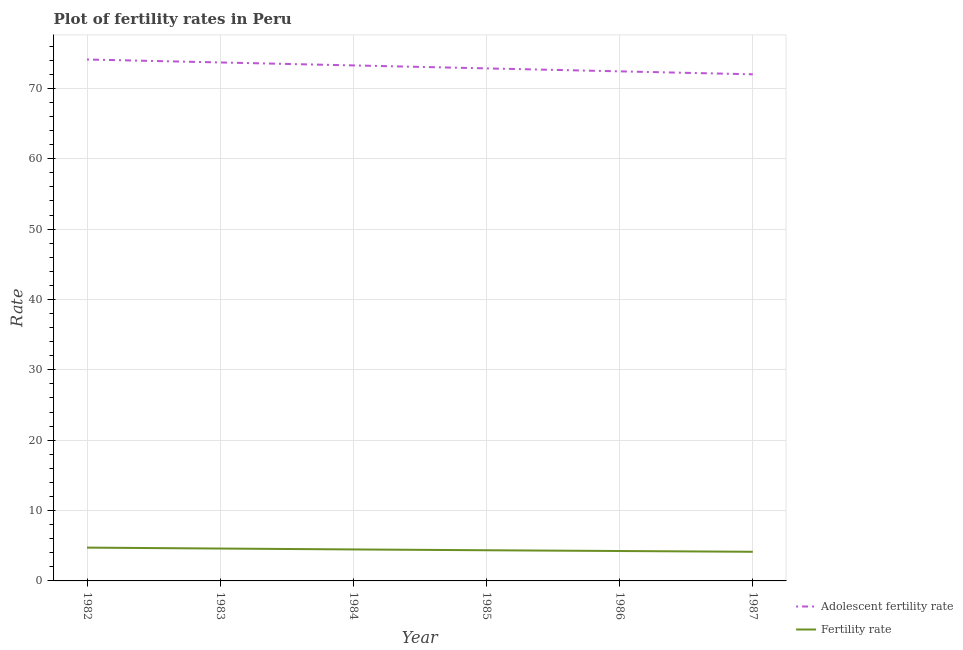How many different coloured lines are there?
Make the answer very short. 2. Is the number of lines equal to the number of legend labels?
Your answer should be compact. Yes. What is the adolescent fertility rate in 1987?
Offer a terse response. 72. Across all years, what is the maximum adolescent fertility rate?
Provide a short and direct response. 74.1. Across all years, what is the minimum fertility rate?
Offer a terse response. 4.14. In which year was the fertility rate maximum?
Offer a very short reply. 1982. In which year was the fertility rate minimum?
Your response must be concise. 1987. What is the total adolescent fertility rate in the graph?
Give a very brief answer. 438.29. What is the difference between the adolescent fertility rate in 1982 and that in 1984?
Your answer should be very brief. 0.84. What is the difference between the adolescent fertility rate in 1986 and the fertility rate in 1983?
Keep it short and to the point. 67.82. What is the average adolescent fertility rate per year?
Ensure brevity in your answer.  73.05. In the year 1984, what is the difference between the fertility rate and adolescent fertility rate?
Provide a short and direct response. -68.78. In how many years, is the adolescent fertility rate greater than 10?
Your response must be concise. 6. What is the ratio of the fertility rate in 1982 to that in 1985?
Keep it short and to the point. 1.09. Is the adolescent fertility rate in 1985 less than that in 1987?
Provide a short and direct response. No. Is the difference between the adolescent fertility rate in 1983 and 1984 greater than the difference between the fertility rate in 1983 and 1984?
Offer a terse response. Yes. What is the difference between the highest and the second highest adolescent fertility rate?
Keep it short and to the point. 0.42. What is the difference between the highest and the lowest fertility rate?
Ensure brevity in your answer.  0.59. Is the adolescent fertility rate strictly greater than the fertility rate over the years?
Ensure brevity in your answer.  Yes. Is the fertility rate strictly less than the adolescent fertility rate over the years?
Offer a very short reply. Yes. How many lines are there?
Your response must be concise. 2. How many years are there in the graph?
Give a very brief answer. 6. Does the graph contain any zero values?
Give a very brief answer. No. Does the graph contain grids?
Keep it short and to the point. Yes. Where does the legend appear in the graph?
Keep it short and to the point. Bottom right. How many legend labels are there?
Give a very brief answer. 2. What is the title of the graph?
Your response must be concise. Plot of fertility rates in Peru. What is the label or title of the Y-axis?
Provide a succinct answer. Rate. What is the Rate of Adolescent fertility rate in 1982?
Provide a succinct answer. 74.1. What is the Rate of Fertility rate in 1982?
Give a very brief answer. 4.73. What is the Rate of Adolescent fertility rate in 1983?
Give a very brief answer. 73.68. What is the Rate of Fertility rate in 1983?
Your answer should be very brief. 4.6. What is the Rate in Adolescent fertility rate in 1984?
Give a very brief answer. 73.26. What is the Rate of Fertility rate in 1984?
Ensure brevity in your answer.  4.47. What is the Rate in Adolescent fertility rate in 1985?
Offer a terse response. 72.84. What is the Rate of Fertility rate in 1985?
Provide a succinct answer. 4.36. What is the Rate in Adolescent fertility rate in 1986?
Your answer should be compact. 72.42. What is the Rate of Fertility rate in 1986?
Keep it short and to the point. 4.25. What is the Rate of Adolescent fertility rate in 1987?
Provide a succinct answer. 72. What is the Rate in Fertility rate in 1987?
Offer a terse response. 4.14. Across all years, what is the maximum Rate of Adolescent fertility rate?
Offer a very short reply. 74.1. Across all years, what is the maximum Rate in Fertility rate?
Give a very brief answer. 4.73. Across all years, what is the minimum Rate in Adolescent fertility rate?
Your response must be concise. 72. Across all years, what is the minimum Rate of Fertility rate?
Your answer should be very brief. 4.14. What is the total Rate in Adolescent fertility rate in the graph?
Ensure brevity in your answer.  438.29. What is the total Rate of Fertility rate in the graph?
Give a very brief answer. 26.56. What is the difference between the Rate in Adolescent fertility rate in 1982 and that in 1983?
Provide a short and direct response. 0.42. What is the difference between the Rate of Fertility rate in 1982 and that in 1983?
Keep it short and to the point. 0.13. What is the difference between the Rate of Adolescent fertility rate in 1982 and that in 1984?
Provide a short and direct response. 0.84. What is the difference between the Rate of Fertility rate in 1982 and that in 1984?
Give a very brief answer. 0.26. What is the difference between the Rate of Adolescent fertility rate in 1982 and that in 1985?
Your answer should be compact. 1.26. What is the difference between the Rate of Fertility rate in 1982 and that in 1985?
Offer a very short reply. 0.38. What is the difference between the Rate in Adolescent fertility rate in 1982 and that in 1986?
Keep it short and to the point. 1.68. What is the difference between the Rate of Fertility rate in 1982 and that in 1986?
Offer a terse response. 0.48. What is the difference between the Rate in Adolescent fertility rate in 1982 and that in 1987?
Your response must be concise. 2.11. What is the difference between the Rate in Fertility rate in 1982 and that in 1987?
Provide a short and direct response. 0.59. What is the difference between the Rate in Adolescent fertility rate in 1983 and that in 1984?
Your response must be concise. 0.42. What is the difference between the Rate of Adolescent fertility rate in 1983 and that in 1985?
Keep it short and to the point. 0.84. What is the difference between the Rate of Fertility rate in 1983 and that in 1985?
Provide a short and direct response. 0.24. What is the difference between the Rate of Adolescent fertility rate in 1983 and that in 1986?
Provide a short and direct response. 1.26. What is the difference between the Rate in Fertility rate in 1983 and that in 1986?
Your response must be concise. 0.35. What is the difference between the Rate in Adolescent fertility rate in 1983 and that in 1987?
Provide a succinct answer. 1.68. What is the difference between the Rate in Fertility rate in 1983 and that in 1987?
Provide a succinct answer. 0.46. What is the difference between the Rate in Adolescent fertility rate in 1984 and that in 1985?
Keep it short and to the point. 0.42. What is the difference between the Rate in Fertility rate in 1984 and that in 1985?
Ensure brevity in your answer.  0.12. What is the difference between the Rate in Adolescent fertility rate in 1984 and that in 1986?
Ensure brevity in your answer.  0.84. What is the difference between the Rate in Fertility rate in 1984 and that in 1986?
Ensure brevity in your answer.  0.23. What is the difference between the Rate of Adolescent fertility rate in 1984 and that in 1987?
Offer a very short reply. 1.26. What is the difference between the Rate in Fertility rate in 1984 and that in 1987?
Make the answer very short. 0.33. What is the difference between the Rate in Adolescent fertility rate in 1985 and that in 1986?
Give a very brief answer. 0.42. What is the difference between the Rate in Fertility rate in 1985 and that in 1986?
Give a very brief answer. 0.11. What is the difference between the Rate of Adolescent fertility rate in 1985 and that in 1987?
Provide a succinct answer. 0.84. What is the difference between the Rate in Fertility rate in 1985 and that in 1987?
Offer a terse response. 0.22. What is the difference between the Rate of Adolescent fertility rate in 1986 and that in 1987?
Give a very brief answer. 0.42. What is the difference between the Rate of Fertility rate in 1986 and that in 1987?
Make the answer very short. 0.11. What is the difference between the Rate of Adolescent fertility rate in 1982 and the Rate of Fertility rate in 1983?
Make the answer very short. 69.5. What is the difference between the Rate in Adolescent fertility rate in 1982 and the Rate in Fertility rate in 1984?
Provide a short and direct response. 69.63. What is the difference between the Rate of Adolescent fertility rate in 1982 and the Rate of Fertility rate in 1985?
Provide a succinct answer. 69.74. What is the difference between the Rate in Adolescent fertility rate in 1982 and the Rate in Fertility rate in 1986?
Offer a very short reply. 69.85. What is the difference between the Rate in Adolescent fertility rate in 1982 and the Rate in Fertility rate in 1987?
Offer a terse response. 69.96. What is the difference between the Rate of Adolescent fertility rate in 1983 and the Rate of Fertility rate in 1984?
Your answer should be very brief. 69.21. What is the difference between the Rate in Adolescent fertility rate in 1983 and the Rate in Fertility rate in 1985?
Give a very brief answer. 69.32. What is the difference between the Rate of Adolescent fertility rate in 1983 and the Rate of Fertility rate in 1986?
Your answer should be very brief. 69.43. What is the difference between the Rate of Adolescent fertility rate in 1983 and the Rate of Fertility rate in 1987?
Make the answer very short. 69.54. What is the difference between the Rate in Adolescent fertility rate in 1984 and the Rate in Fertility rate in 1985?
Your response must be concise. 68.9. What is the difference between the Rate in Adolescent fertility rate in 1984 and the Rate in Fertility rate in 1986?
Keep it short and to the point. 69.01. What is the difference between the Rate in Adolescent fertility rate in 1984 and the Rate in Fertility rate in 1987?
Your response must be concise. 69.12. What is the difference between the Rate of Adolescent fertility rate in 1985 and the Rate of Fertility rate in 1986?
Offer a terse response. 68.59. What is the difference between the Rate of Adolescent fertility rate in 1985 and the Rate of Fertility rate in 1987?
Keep it short and to the point. 68.7. What is the difference between the Rate in Adolescent fertility rate in 1986 and the Rate in Fertility rate in 1987?
Offer a very short reply. 68.28. What is the average Rate in Adolescent fertility rate per year?
Ensure brevity in your answer.  73.05. What is the average Rate in Fertility rate per year?
Provide a succinct answer. 4.43. In the year 1982, what is the difference between the Rate in Adolescent fertility rate and Rate in Fertility rate?
Your answer should be compact. 69.37. In the year 1983, what is the difference between the Rate of Adolescent fertility rate and Rate of Fertility rate?
Offer a terse response. 69.08. In the year 1984, what is the difference between the Rate of Adolescent fertility rate and Rate of Fertility rate?
Provide a succinct answer. 68.78. In the year 1985, what is the difference between the Rate in Adolescent fertility rate and Rate in Fertility rate?
Offer a very short reply. 68.48. In the year 1986, what is the difference between the Rate in Adolescent fertility rate and Rate in Fertility rate?
Your answer should be compact. 68.17. In the year 1987, what is the difference between the Rate of Adolescent fertility rate and Rate of Fertility rate?
Your answer should be very brief. 67.85. What is the ratio of the Rate of Adolescent fertility rate in 1982 to that in 1983?
Your answer should be very brief. 1.01. What is the ratio of the Rate in Fertility rate in 1982 to that in 1983?
Give a very brief answer. 1.03. What is the ratio of the Rate of Adolescent fertility rate in 1982 to that in 1984?
Ensure brevity in your answer.  1.01. What is the ratio of the Rate of Fertility rate in 1982 to that in 1984?
Make the answer very short. 1.06. What is the ratio of the Rate in Adolescent fertility rate in 1982 to that in 1985?
Offer a terse response. 1.02. What is the ratio of the Rate of Fertility rate in 1982 to that in 1985?
Your response must be concise. 1.09. What is the ratio of the Rate of Adolescent fertility rate in 1982 to that in 1986?
Provide a succinct answer. 1.02. What is the ratio of the Rate of Fertility rate in 1982 to that in 1986?
Offer a terse response. 1.11. What is the ratio of the Rate in Adolescent fertility rate in 1982 to that in 1987?
Keep it short and to the point. 1.03. What is the ratio of the Rate in Fertility rate in 1982 to that in 1987?
Offer a very short reply. 1.14. What is the ratio of the Rate of Adolescent fertility rate in 1983 to that in 1984?
Your response must be concise. 1.01. What is the ratio of the Rate of Fertility rate in 1983 to that in 1984?
Offer a very short reply. 1.03. What is the ratio of the Rate in Adolescent fertility rate in 1983 to that in 1985?
Keep it short and to the point. 1.01. What is the ratio of the Rate in Fertility rate in 1983 to that in 1985?
Ensure brevity in your answer.  1.06. What is the ratio of the Rate of Adolescent fertility rate in 1983 to that in 1986?
Your answer should be very brief. 1.02. What is the ratio of the Rate of Fertility rate in 1983 to that in 1986?
Offer a terse response. 1.08. What is the ratio of the Rate of Adolescent fertility rate in 1983 to that in 1987?
Offer a terse response. 1.02. What is the ratio of the Rate of Fertility rate in 1983 to that in 1987?
Give a very brief answer. 1.11. What is the ratio of the Rate in Adolescent fertility rate in 1984 to that in 1985?
Your response must be concise. 1.01. What is the ratio of the Rate in Fertility rate in 1984 to that in 1985?
Your answer should be very brief. 1.03. What is the ratio of the Rate of Adolescent fertility rate in 1984 to that in 1986?
Offer a terse response. 1.01. What is the ratio of the Rate in Fertility rate in 1984 to that in 1986?
Offer a very short reply. 1.05. What is the ratio of the Rate in Adolescent fertility rate in 1984 to that in 1987?
Your response must be concise. 1.02. What is the ratio of the Rate of Fertility rate in 1984 to that in 1987?
Give a very brief answer. 1.08. What is the ratio of the Rate in Fertility rate in 1985 to that in 1986?
Your answer should be compact. 1.03. What is the ratio of the Rate in Adolescent fertility rate in 1985 to that in 1987?
Provide a short and direct response. 1.01. What is the ratio of the Rate of Fertility rate in 1985 to that in 1987?
Your answer should be compact. 1.05. What is the ratio of the Rate in Adolescent fertility rate in 1986 to that in 1987?
Provide a succinct answer. 1.01. What is the ratio of the Rate in Fertility rate in 1986 to that in 1987?
Provide a short and direct response. 1.03. What is the difference between the highest and the second highest Rate of Adolescent fertility rate?
Keep it short and to the point. 0.42. What is the difference between the highest and the second highest Rate in Fertility rate?
Ensure brevity in your answer.  0.13. What is the difference between the highest and the lowest Rate of Adolescent fertility rate?
Make the answer very short. 2.11. What is the difference between the highest and the lowest Rate in Fertility rate?
Offer a terse response. 0.59. 